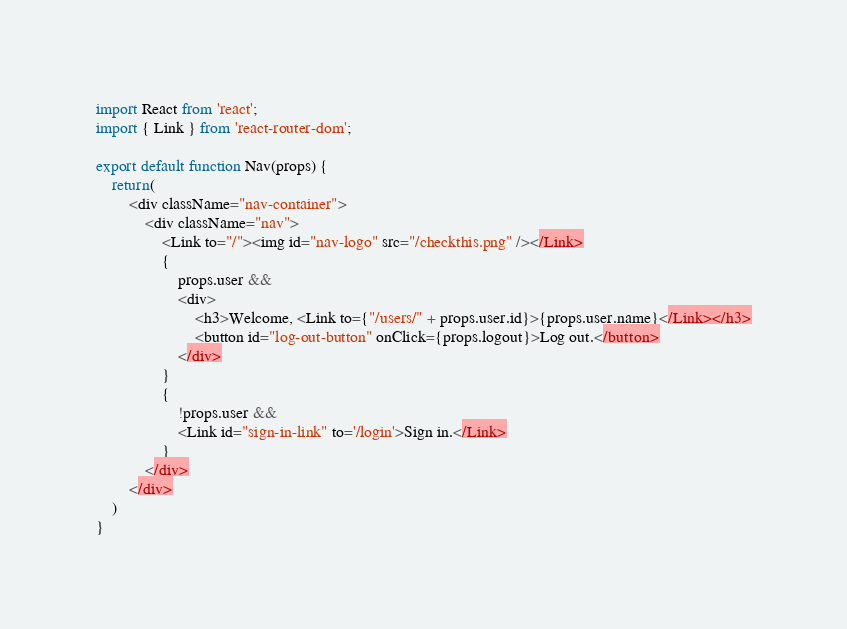<code> <loc_0><loc_0><loc_500><loc_500><_JavaScript_>import React from 'react';
import { Link } from 'react-router-dom';

export default function Nav(props) {
    return(
        <div className="nav-container">
            <div className="nav">
                <Link to="/"><img id="nav-logo" src="/checkthis.png" /></Link>
                {
                    props.user && 
                    <div>
                        <h3>Welcome, <Link to={"/users/" + props.user.id}>{props.user.name}</Link></h3>
                        <button id="log-out-button" onClick={props.logout}>Log out.</button>
                    </div>
                }
                {
                    !props.user &&
                    <Link id="sign-in-link" to='/login'>Sign in.</Link>
                }
            </div>
        </div>
    )
}</code> 